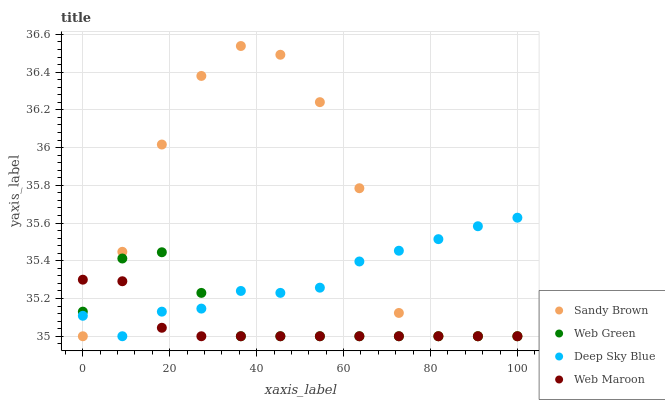Does Web Maroon have the minimum area under the curve?
Answer yes or no. Yes. Does Sandy Brown have the maximum area under the curve?
Answer yes or no. Yes. Does Deep Sky Blue have the minimum area under the curve?
Answer yes or no. No. Does Deep Sky Blue have the maximum area under the curve?
Answer yes or no. No. Is Web Maroon the smoothest?
Answer yes or no. Yes. Is Sandy Brown the roughest?
Answer yes or no. Yes. Is Deep Sky Blue the smoothest?
Answer yes or no. No. Is Deep Sky Blue the roughest?
Answer yes or no. No. Does Web Maroon have the lowest value?
Answer yes or no. Yes. Does Deep Sky Blue have the lowest value?
Answer yes or no. No. Does Sandy Brown have the highest value?
Answer yes or no. Yes. Does Deep Sky Blue have the highest value?
Answer yes or no. No. Does Web Green intersect Sandy Brown?
Answer yes or no. Yes. Is Web Green less than Sandy Brown?
Answer yes or no. No. Is Web Green greater than Sandy Brown?
Answer yes or no. No. 